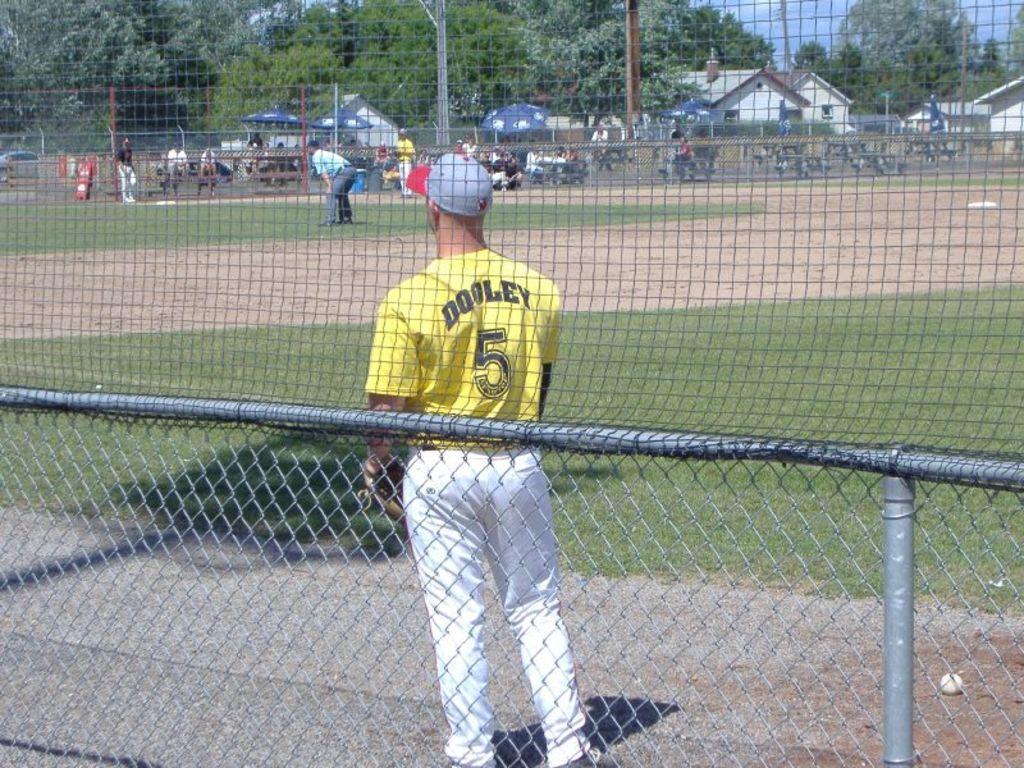How would you summarize this image in a sentence or two? In this picture we can see the grass, ball, fencing net and two people are standing on the ground. In the background we can see some people, umbrellas, buildings, trees, vehicles, some objects and the sky. 